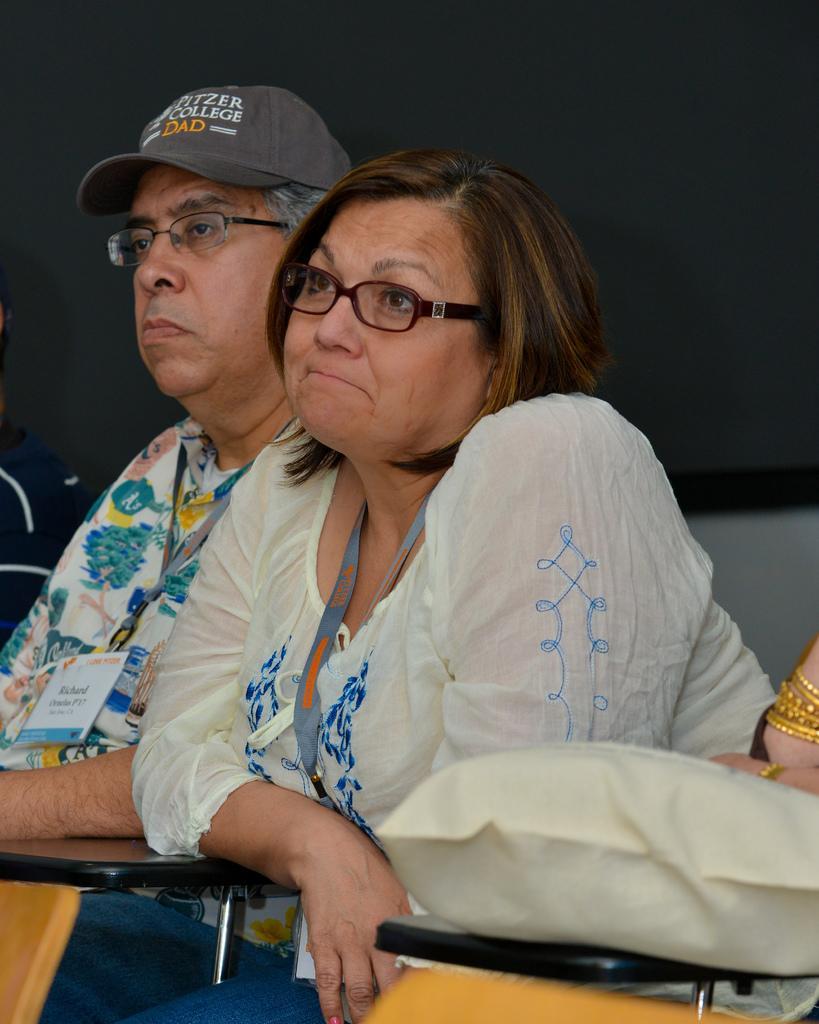Please provide a concise description of this image. In this image we can see man and a woman. They are wearing specs and tags. Man is wearing a cap. Near to them there are stands. In the back there is a wall. 